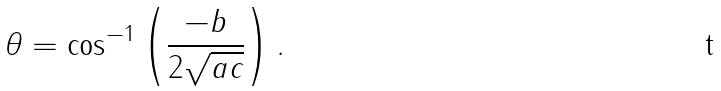Convert formula to latex. <formula><loc_0><loc_0><loc_500><loc_500>\theta = \cos ^ { - 1 } \left ( { \frac { - b } { 2 { \sqrt { a c } } } } \right ) .</formula> 